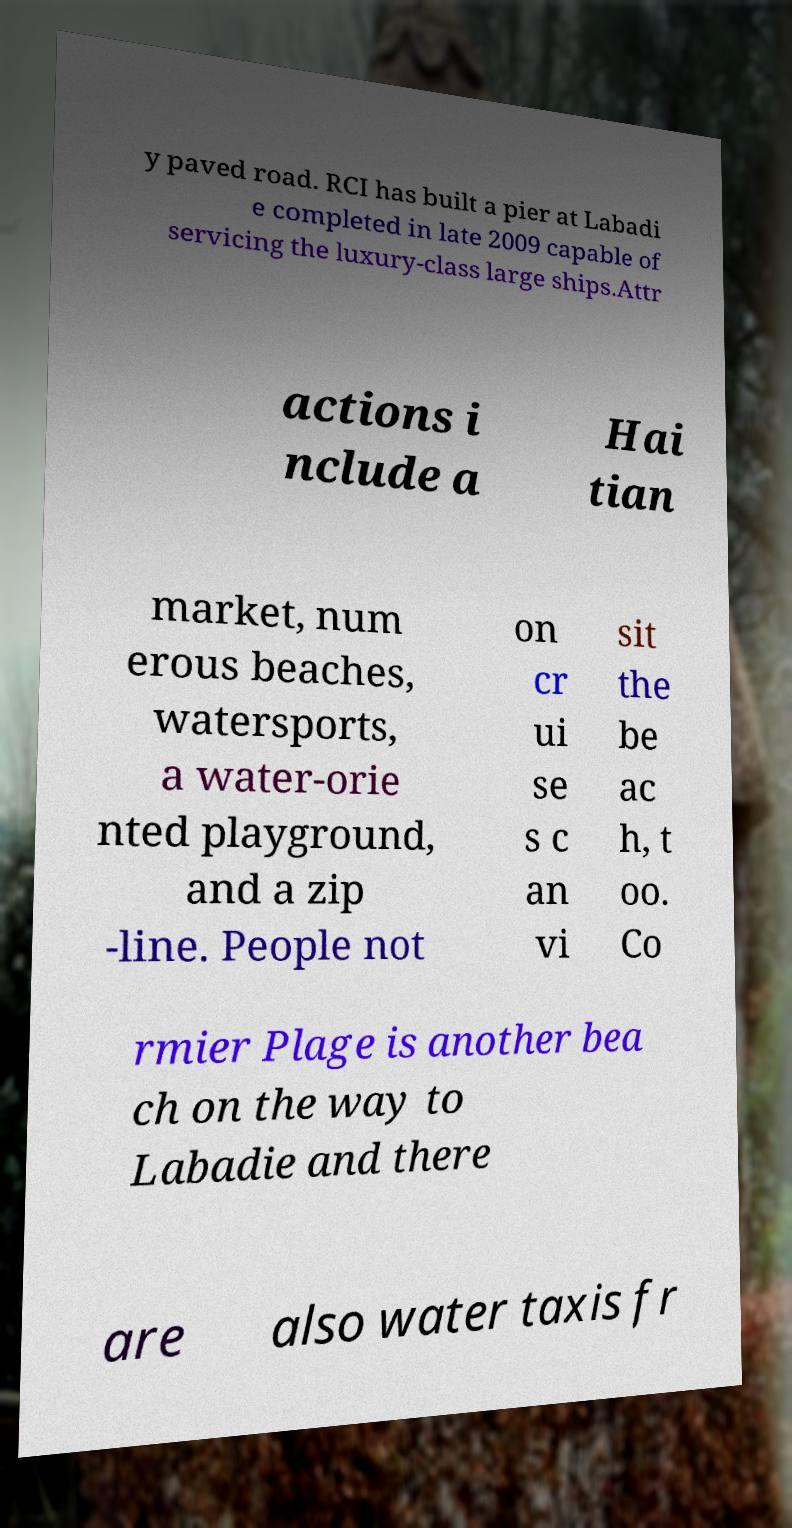There's text embedded in this image that I need extracted. Can you transcribe it verbatim? y paved road. RCI has built a pier at Labadi e completed in late 2009 capable of servicing the luxury-class large ships.Attr actions i nclude a Hai tian market, num erous beaches, watersports, a water-orie nted playground, and a zip -line. People not on cr ui se s c an vi sit the be ac h, t oo. Co rmier Plage is another bea ch on the way to Labadie and there are also water taxis fr 